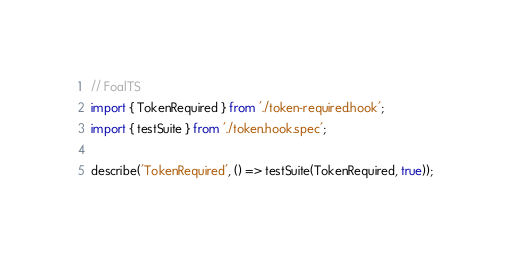Convert code to text. <code><loc_0><loc_0><loc_500><loc_500><_TypeScript_>// FoalTS
import { TokenRequired } from './token-required.hook';
import { testSuite } from './token.hook.spec';

describe('TokenRequired', () => testSuite(TokenRequired, true));
</code> 